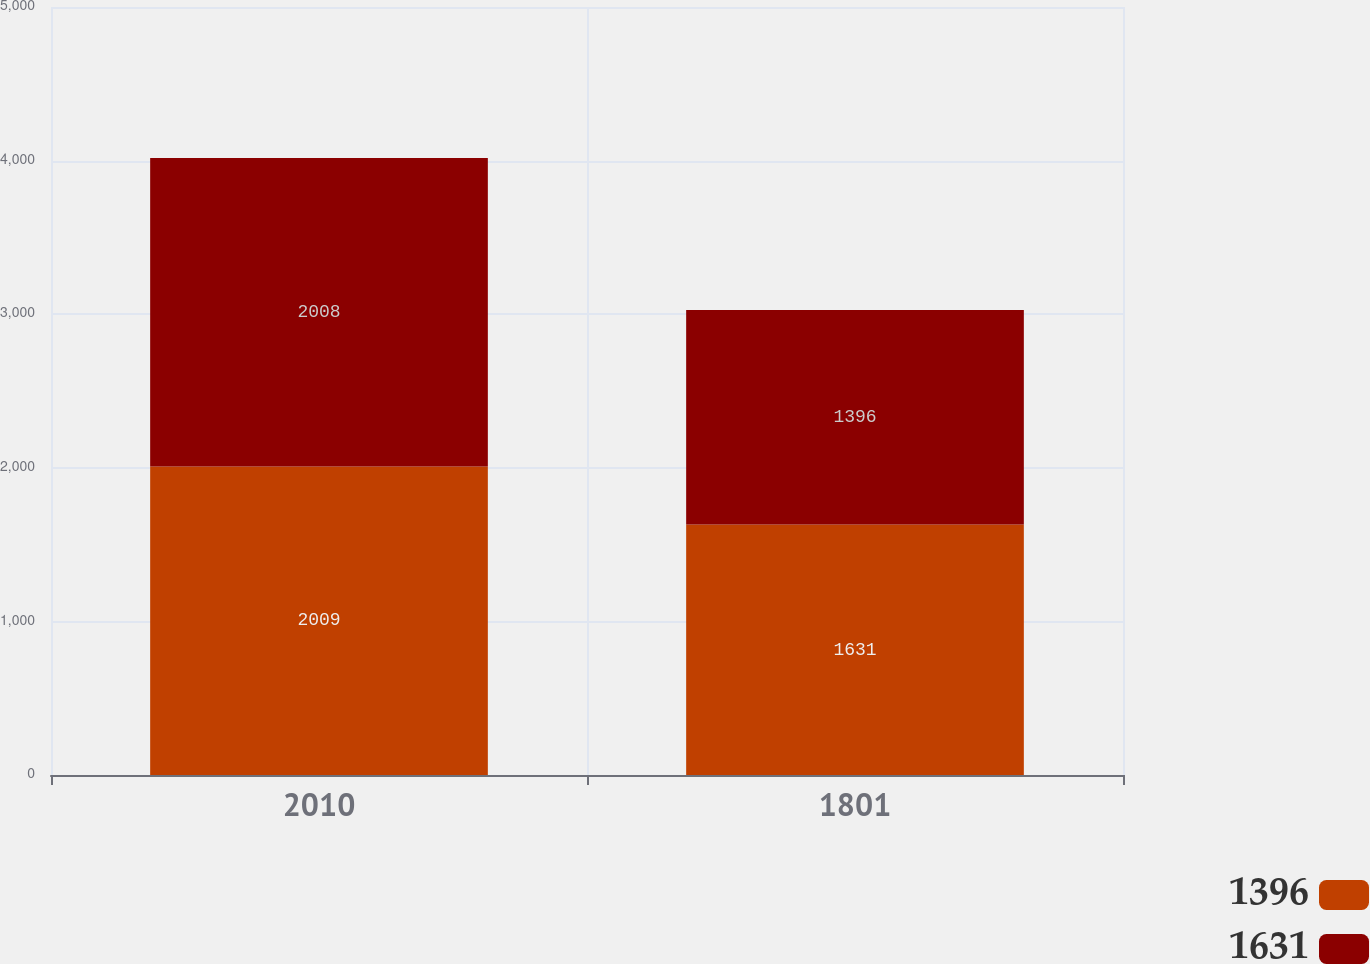Convert chart to OTSL. <chart><loc_0><loc_0><loc_500><loc_500><stacked_bar_chart><ecel><fcel>2010<fcel>1801<nl><fcel>1396<fcel>2009<fcel>1631<nl><fcel>1631<fcel>2008<fcel>1396<nl></chart> 